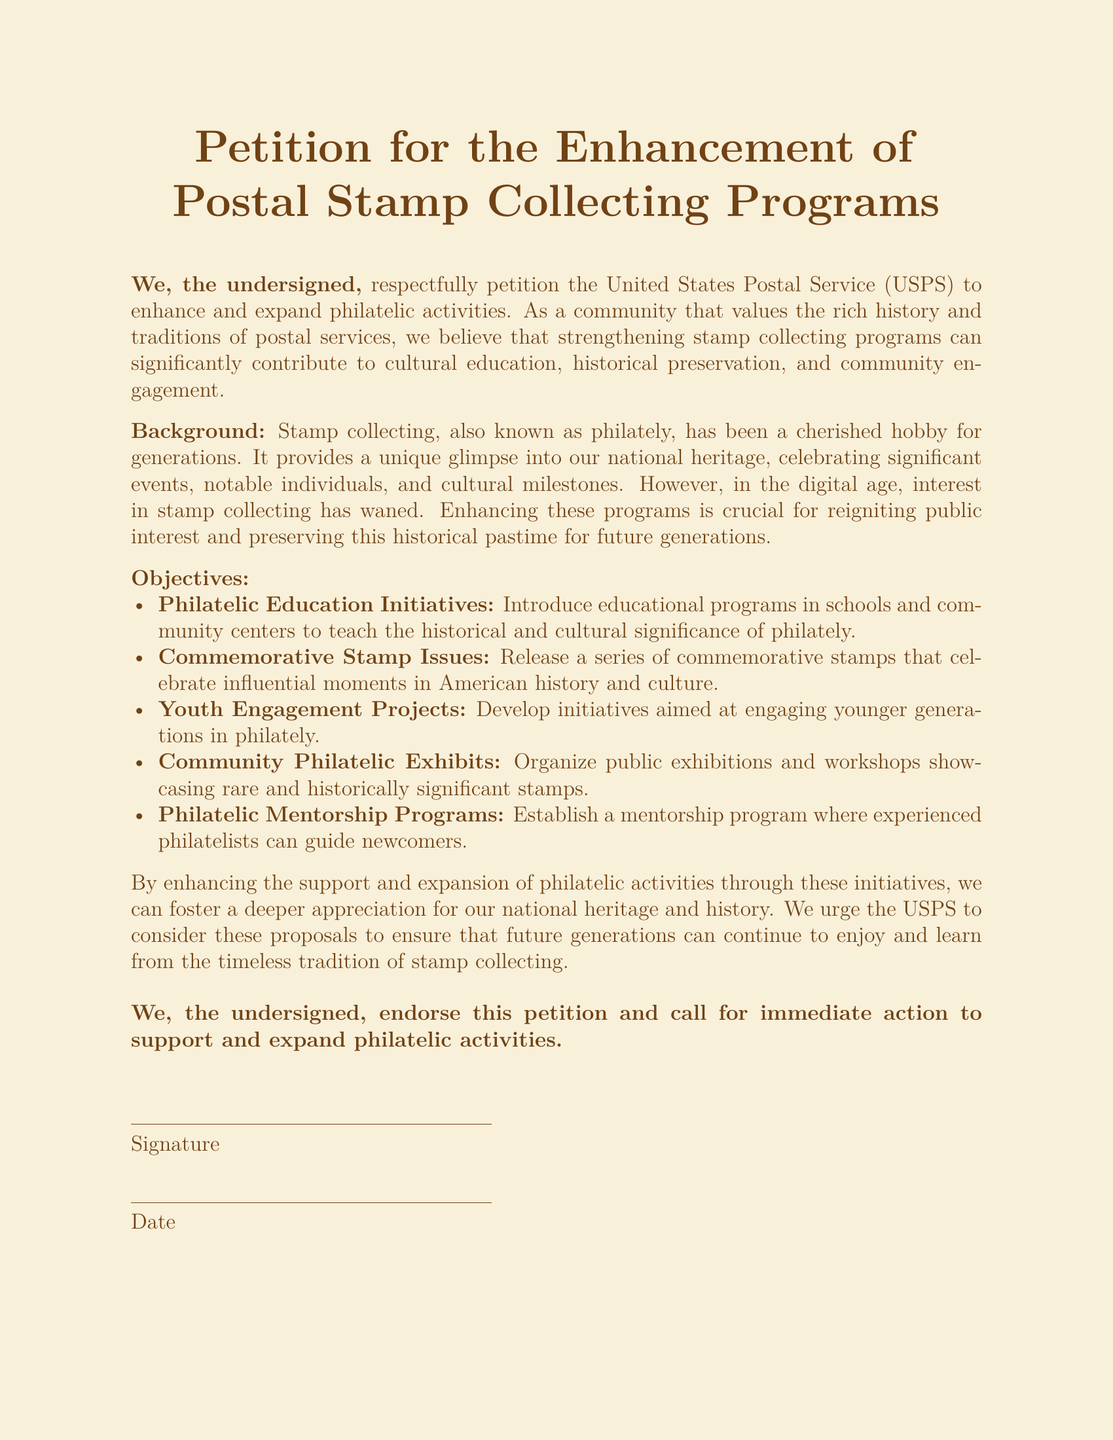What is the title of the petition? The title is prominently displayed at the top of the document, specifying the purpose of the petition.
Answer: Petition for the Enhancement of Postal Stamp Collecting Programs What entity is this petition directed to? The petition explicitly mentions the recipient organization responsible for postal services in the United States.
Answer: United States Postal Service What is one of the objectives listed in the document? The objectives outline specific initiatives intended to enhance philatelic activities, as detailed in the document.
Answer: Philatelic Education Initiatives How many objectives are mentioned in the document? The document lists a series of defined goals, specifically outlining each aim for enhancement.
Answer: Five What is the purpose of commemorative stamp issues? The document states that commemorative stamps celebrate important historical and cultural moments.
Answer: Influential moments in American history and culture What does the petition urge the USPS to do? The petition contains a clear call to action related to expanding and supporting philatelic activities.
Answer: Consider these proposals What type of projects does the petition propose to engage younger generations? The document mentions specific initiatives aimed at attracting younger individuals to the hobby of philately.
Answer: Youth Engagement Projects What does the petition advocate for in terms of community events? One of the objectives revolves around public engagement through showcasing philately related events.
Answer: Community Philatelic Exhibits 